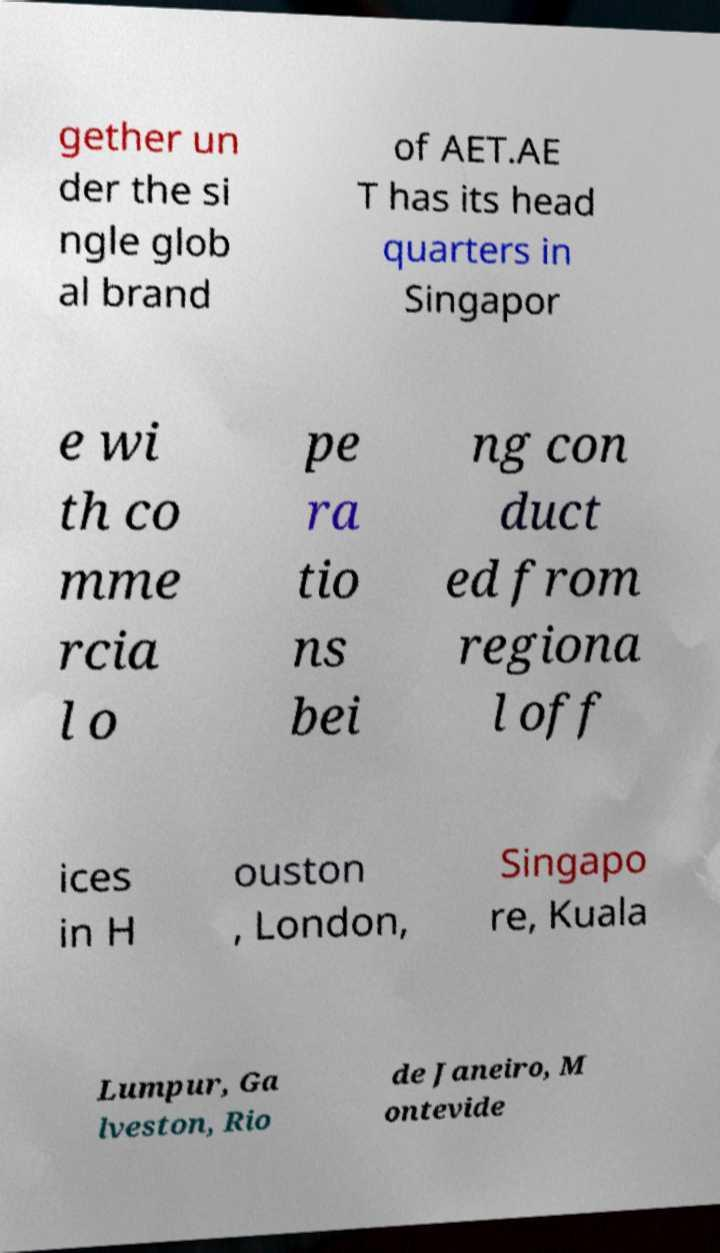Could you extract and type out the text from this image? gether un der the si ngle glob al brand of AET.AE T has its head quarters in Singapor e wi th co mme rcia l o pe ra tio ns bei ng con duct ed from regiona l off ices in H ouston , London, Singapo re, Kuala Lumpur, Ga lveston, Rio de Janeiro, M ontevide 